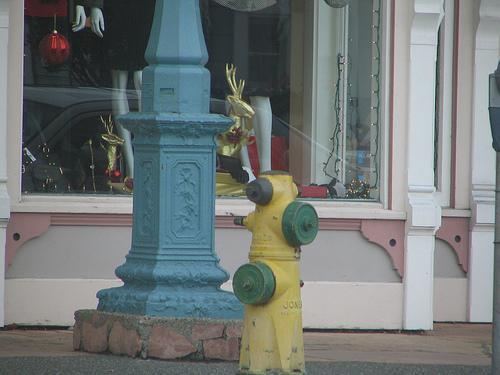How many people are there?
Give a very brief answer. 0. How many mannequins are on display?
Give a very brief answer. 3. 